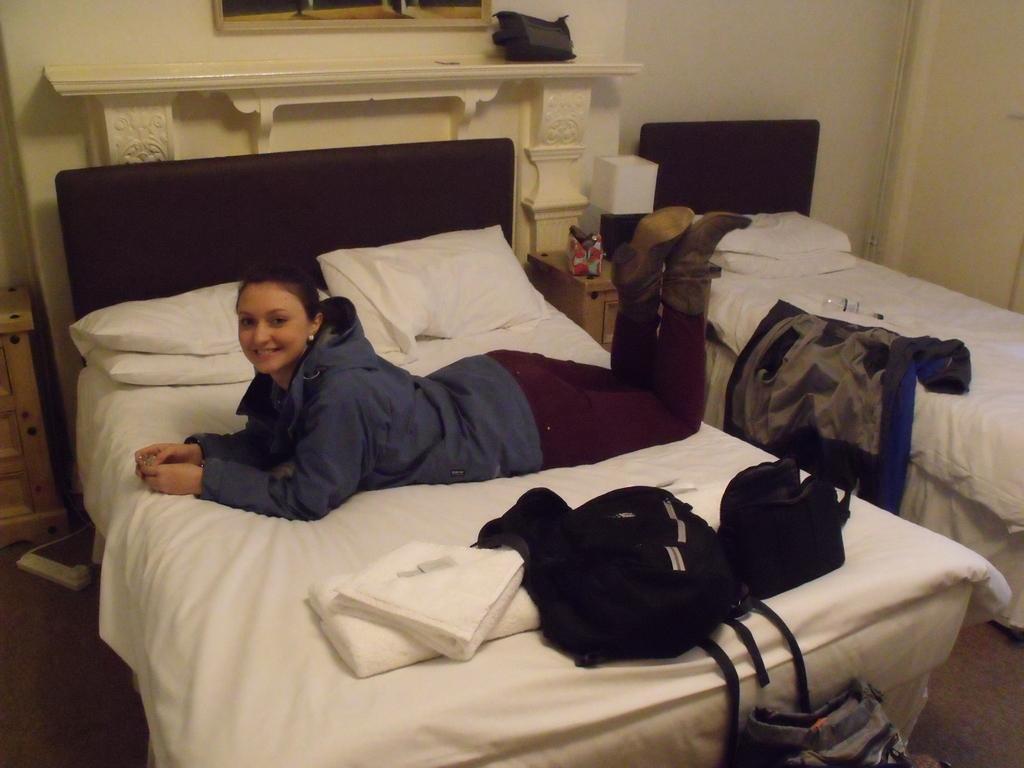How would you summarize this image in a sentence or two? In this image I can see the person lying on the bed. The person is wearing the blue and purple color dress. To the side of that person I can see some clothes and bags. To the right I can see another bed and some pillows on it. In-between two beds there is a table and some objects on it and I can also see the lamp on it. In the back there is a window and the wall. 